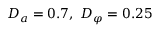<formula> <loc_0><loc_0><loc_500><loc_500>D _ { a } = 0 . 7 , D _ { \varphi } = 0 . 2 5</formula> 